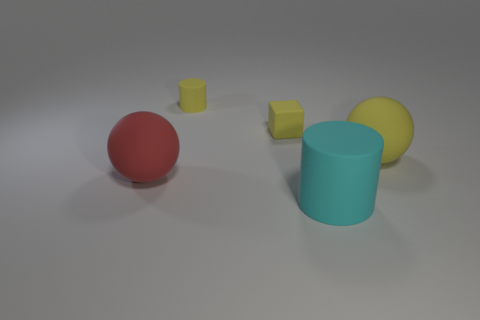Is the size of the matte cylinder on the right side of the yellow matte block the same as the tiny yellow matte cube?
Ensure brevity in your answer.  No. How many other tiny objects are the same shape as the cyan thing?
Give a very brief answer. 1. There is a yellow cylinder that is made of the same material as the small yellow cube; what size is it?
Give a very brief answer. Small. Are there the same number of cyan matte objects that are behind the small yellow cube and tiny blue metallic objects?
Your answer should be compact. Yes. Is the color of the tiny rubber cylinder the same as the tiny rubber block?
Offer a very short reply. Yes. There is a yellow thing on the right side of the yellow matte cube; does it have the same shape as the big object to the left of the small yellow cylinder?
Your answer should be very brief. Yes. What is the color of the object that is to the right of the tiny matte block and behind the red thing?
Offer a terse response. Yellow. There is a big ball in front of the rubber ball on the right side of the cyan matte cylinder; is there a matte cylinder that is in front of it?
Give a very brief answer. Yes. What number of objects are either rubber blocks or red rubber spheres?
Offer a very short reply. 2. Is there anything else of the same color as the big rubber cylinder?
Your answer should be compact. No. 